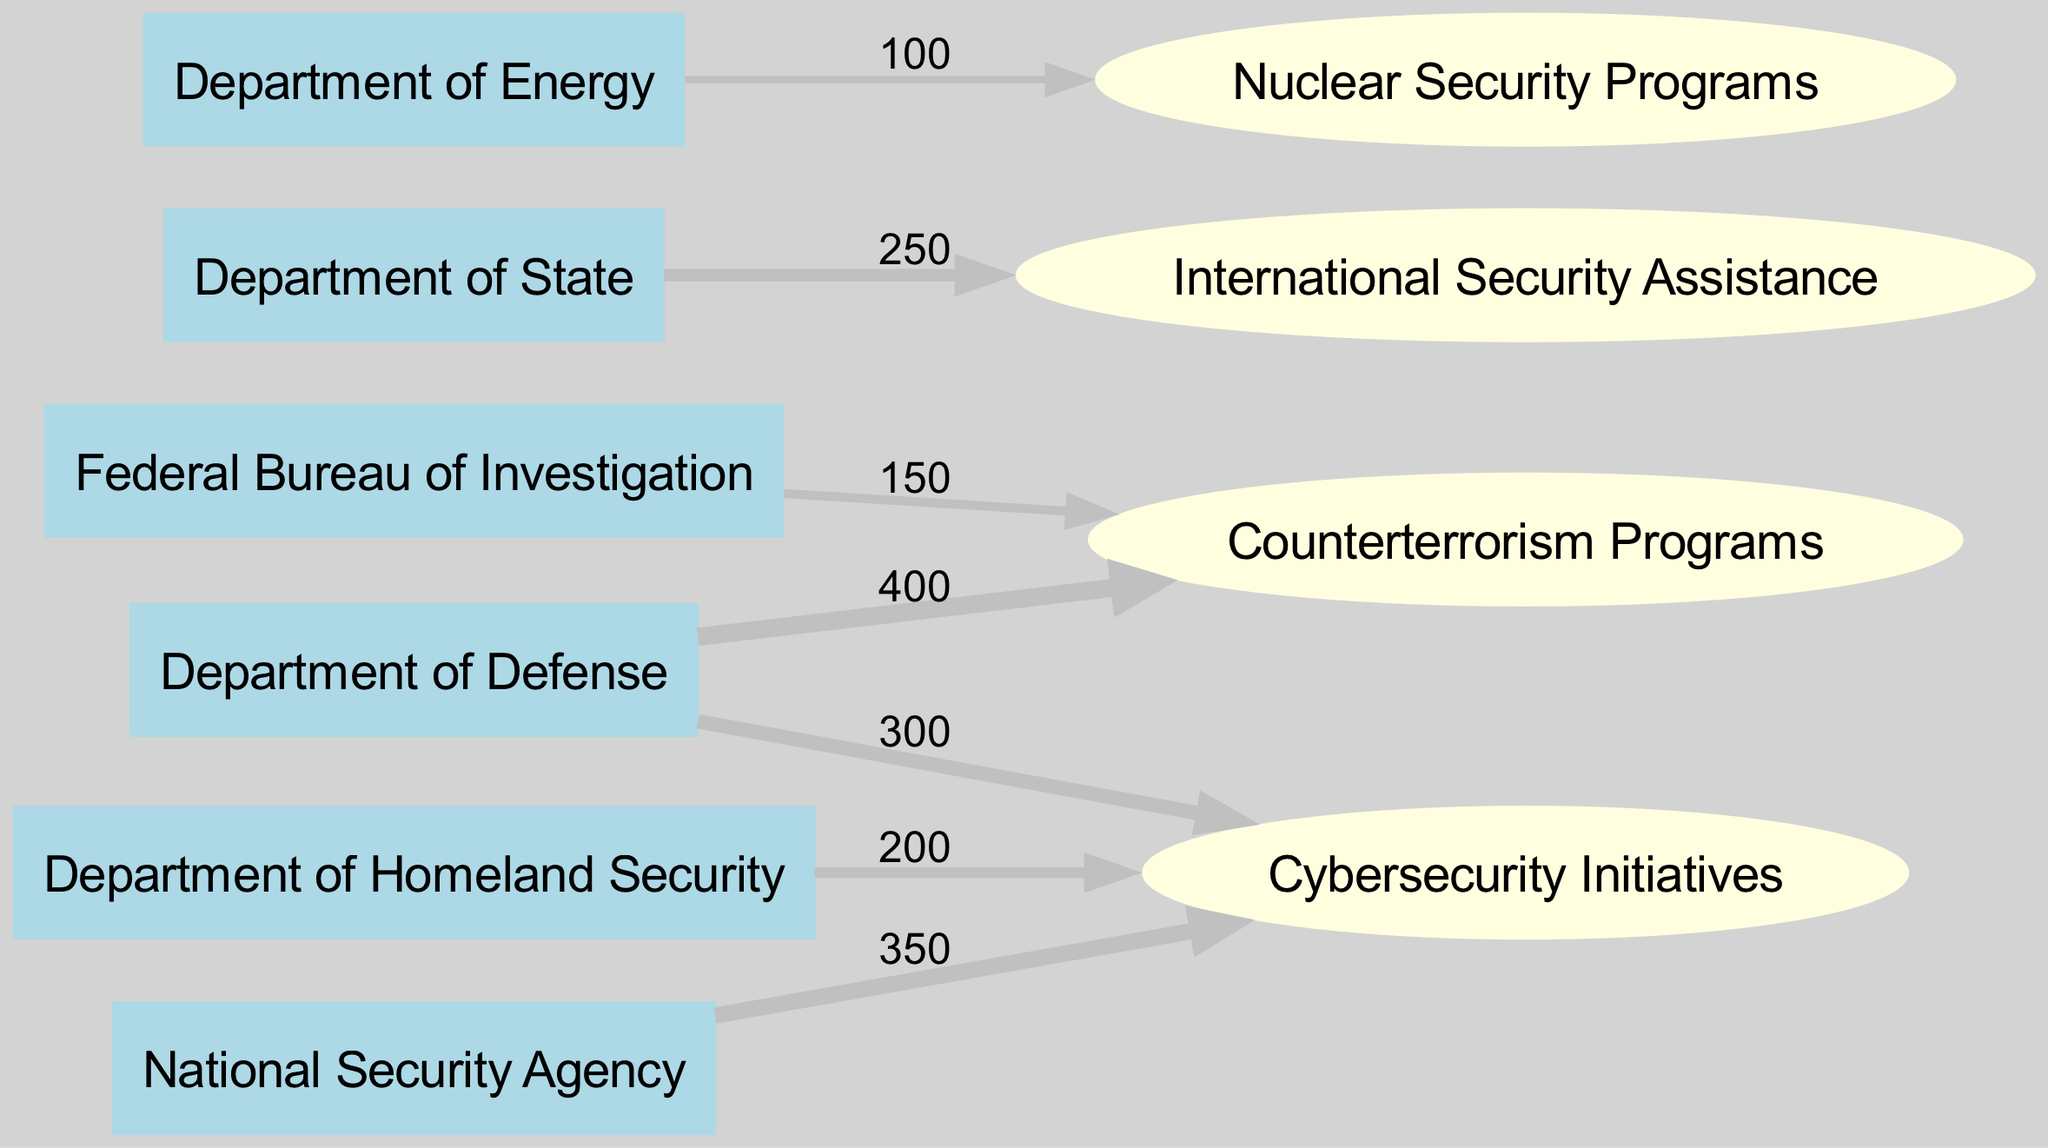What is the total budget allocated to Counterterrorism Programs? To find the total budget allocated to Counterterrorism Programs, we sum the values coming into it from different departments. The Department of Defense contributes 400, and the Federal Bureau of Investigation contributes 150. Therefore, the total is 400 + 150 = 550.
Answer: 550 Which department contributes the most to Cybersecurity Initiatives? By examining the links to Cybersecurity Initiatives, we see that the National Security Agency contributes the most, with a value of 350, which is greater than any contributions from other departments.
Answer: National Security Agency How many total nodes are displayed in the diagram? The total number of nodes is calculated by counting each unique node listed in the data. There are six departments and four programs, resulting in 10 total nodes (6 + 4 = 10).
Answer: 10 What is the total value of budget flows from the Department of Defense? To determine the total budget flow from the Department of Defense, we examine the outgoing links: it contributes 400 to Counterterrorism Programs and 300 to Cybersecurity Initiatives. Adding these amounts gives 400 + 300 = 700.
Answer: 700 Which program receives the least budget allocation? We analyze the values allocated to each program. The Nuclear Security Programs from the Department of Energy has the lowest allocation at 100, which is less than the other programs' allocations.
Answer: Nuclear Security Programs How many departments allocate budget towards Cybersecurity Initiatives? We check the links directed towards Cybersecurity Initiatives to identify the departments. The Department of Defense contributes 300, the Department of Homeland Security contributes 200, and the National Security Agency contributes 350. Thus, three departments allocate budget towards it.
Answer: 3 What is the relationship between the Department of State and International Security Assistance? The link from the Department of State to International Security Assistance indicates that it allocates a budget of 250. Thus, there is a direct relationship where the Department of State financially supports this program.
Answer: 250 Which program has the highest incoming budget allocation? By reviewing the total values for each program, we find Counterterrorism Programs with a total of 550 (400 from Department of Defense + 150 from Federal Bureau of Investigation) and compare it with others. Therefore, Counterterrorism Programs has the highest incoming budget allocation.
Answer: Counterterrorism Programs 